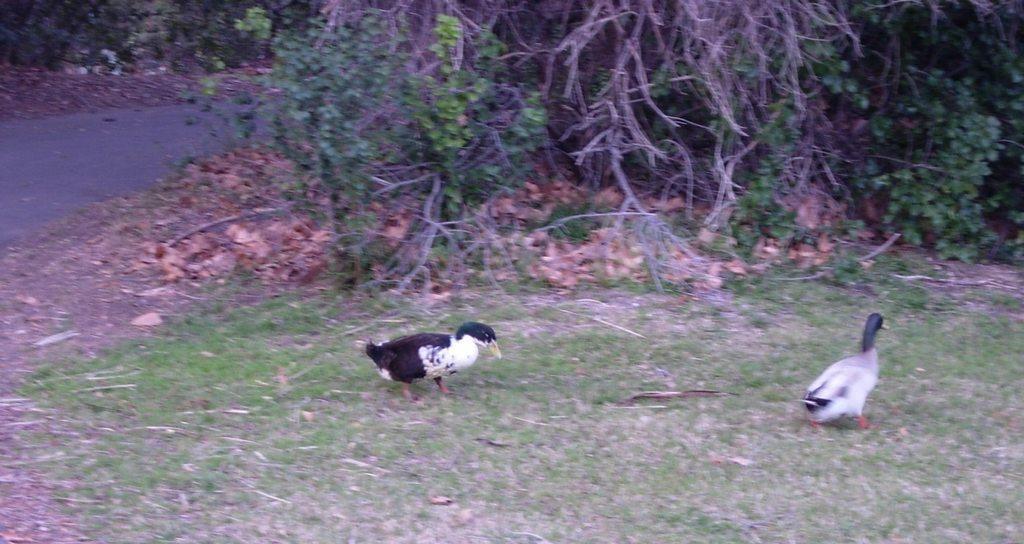In one or two sentences, can you explain what this image depicts? In this picture we can see two birds on the grass. There is a road and a few trees in the background. 